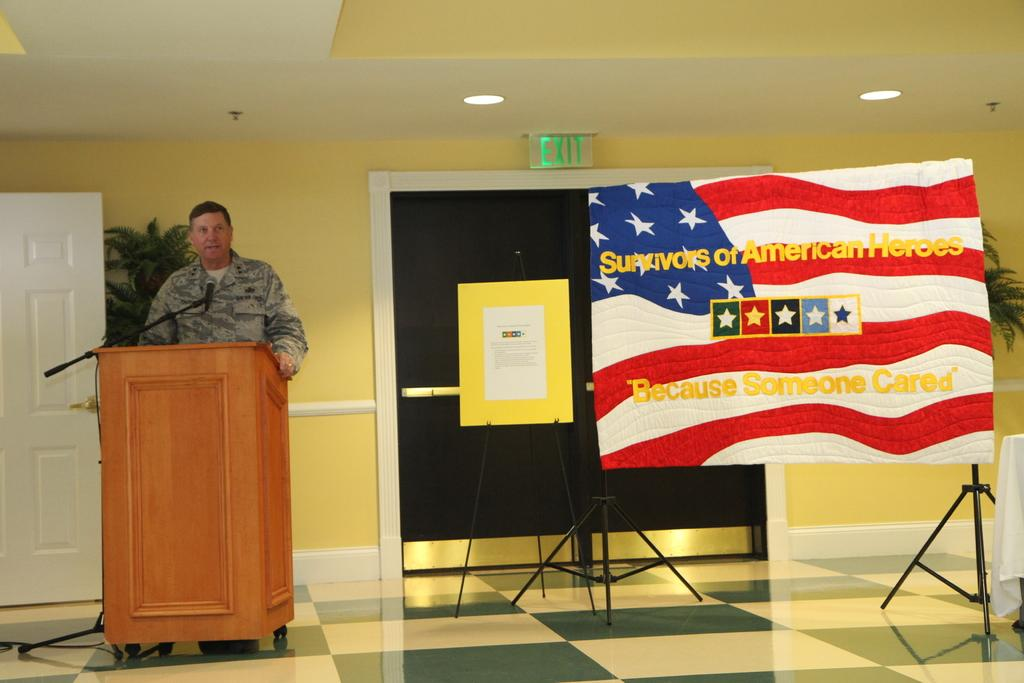What is the person in the image doing? The person is standing in front of the podium. What is the person likely to use in the image? The person might use the mic in the image. What type of visual aids are present in the image? There are colorful boards in the image. What are the stands used for in the image? The stands are likely used to hold the colorful boards. What type of lighting is present in the image? There are lights in the image. What type of greenery is present in the image? There are plants in the image. What is the exit or entrance in the image? There is a door in the image. What is the color of the wall in the image? The wall is yellow in color. How many hands are visible in the image? There are no hands visible in the image. What type of trees can be seen in the image? There are no trees present in the image. 